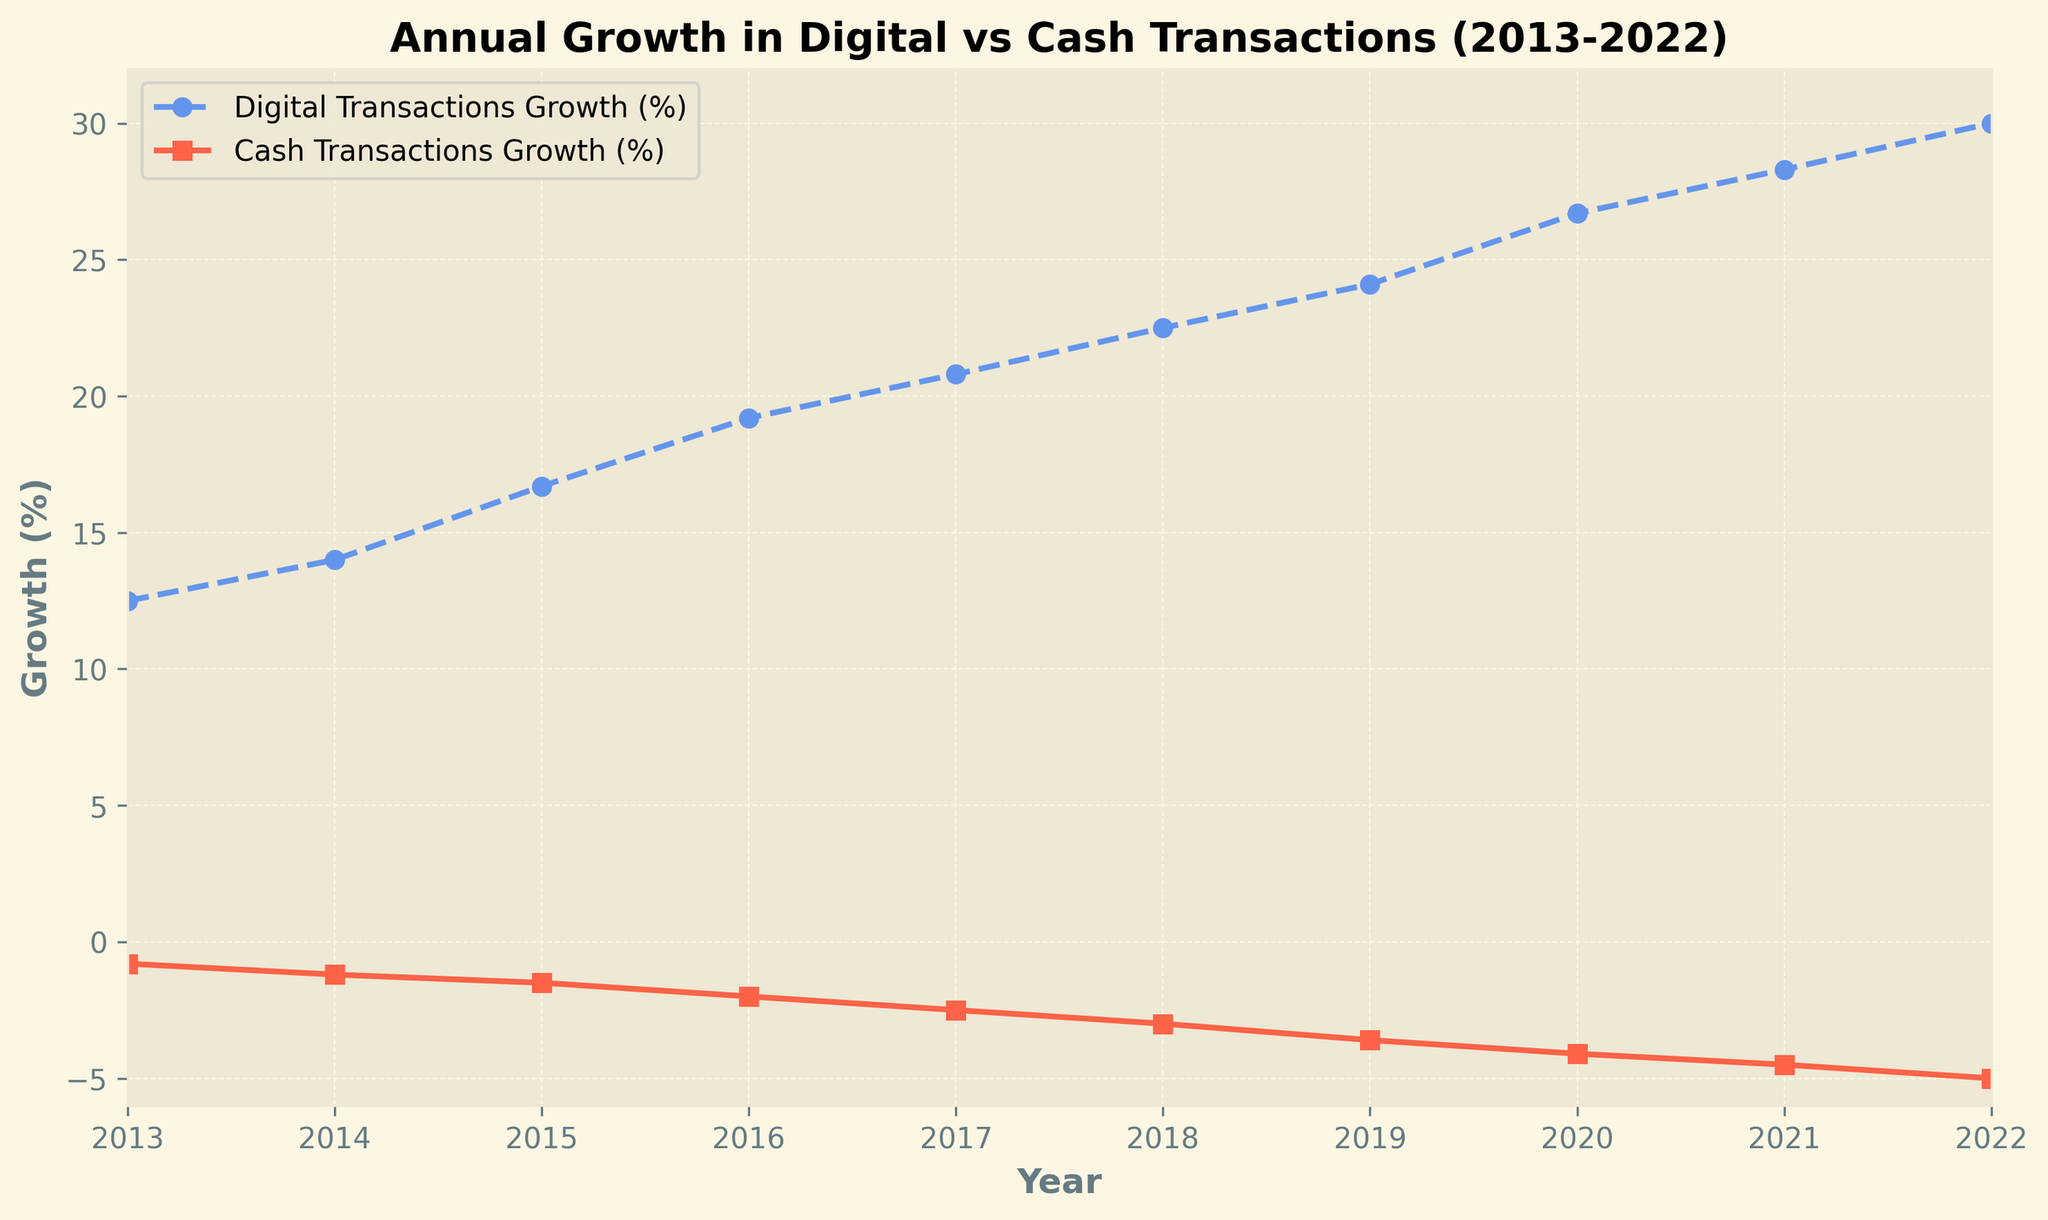What is the overall trend for digital transactions growth over the past decade? The line chart shows that the growth rate for digital transactions has increased steadily from 12.5% in 2013 to 30.0% in 2022.
Answer: Increasing What is the overall trend for cash transactions growth over the past decade? The line chart shows that the growth rate for cash transactions has decreased steadily from -0.8% in 2013 to -5.0% in 2022.
Answer: Decreasing In which year did the growth in digital transactions surpass 20%? By observing the line for digital transactions, it is clear that the growth rate surpassed 20% in 2017.
Answer: 2017 What is the difference in cash transactions growth between 2015 and 2020? The growth rate for cash transactions was -1.5% in 2015 and -4.1% in 2020. The difference is calculated as -4.1 - (-1.5) = -2.6%.
Answer: -2.6% Which year experienced the highest growth rate in digital transactions? The highest point on the digital transactions growth line is in 2022, where it peaked at 30.0%.
Answer: 2022 Compare the growth rates of digital and cash transactions in 2014. Which one was higher? In 2014, the digital transactions growth rate was 14.0%, while cash transactions had a growth rate of -1.2%. Therefore, digital transactions had a higher growth rate.
Answer: Digital transactions Calculate the average annual growth rate of digital transactions over the decade. Summing up the annual growth rates for digital transactions (12.5, 14.0, 16.7, 19.2, 20.8, 22.5, 24.1, 26.7, 28.3, 30.0) gives 215.8%. Dividing by 10 (number of years) yields an average of 21.58%.
Answer: 21.58% Identify the year in which the decline in cash transactions was the steepest. The steepest decline is represented by the largest absolute difference between consecutive years. Between 2017 and 2018, the growth rate dropped from -2.5% to -3.0%, showing a decline of 0.5%.
Answer: 2018 How does the growth rate of digital transactions in 2022 compare to that in 2013? In 2022, the growth rate for digital transactions was 30.0%, which is significantly higher compared to 12.5% in 2013.
Answer: Higher in 2022 If the current trends continue, what might be the expected growth rate for cash transactions in 2023? Given the stable downward trend, the cash transactions growth rate has been decreasing by an average of around 0.5% per year. For 2023, it could be expected to decrease by another 0.5%, reaching approximately -5.5%.
Answer: -5.5% 